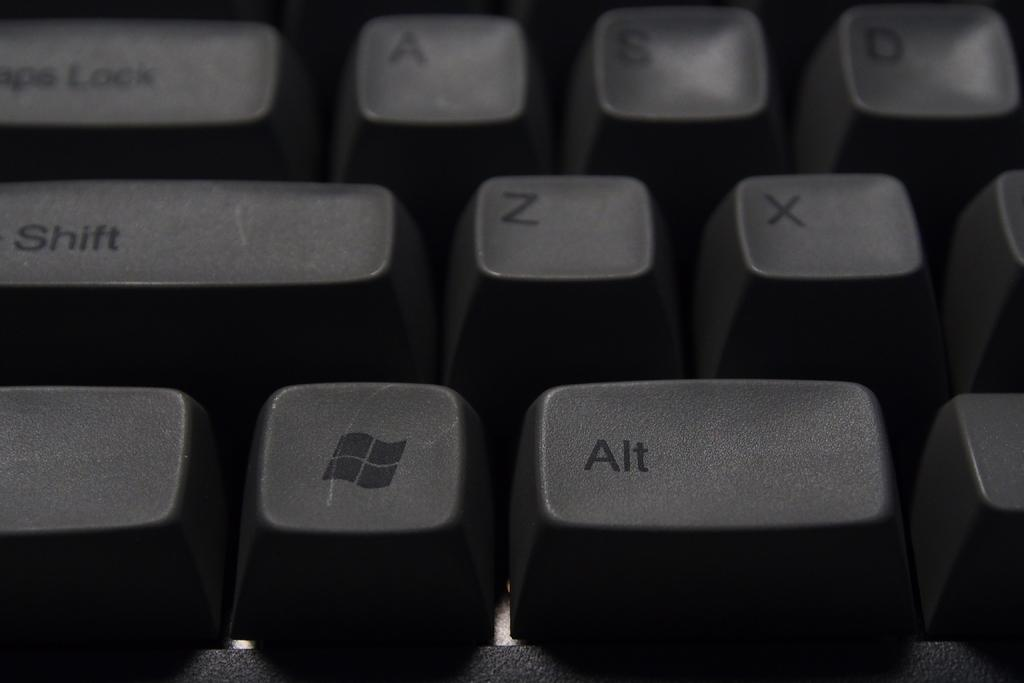<image>
Share a concise interpretation of the image provided. The word Alt is next to the windows logo. 